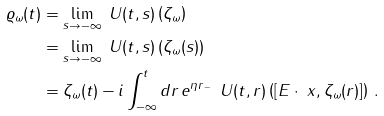Convert formula to latex. <formula><loc_0><loc_0><loc_500><loc_500>\varrho _ { \omega } ( t ) & = \lim _ { s \to - \infty } { \ U } ( t , s ) \left ( { \zeta } _ { \omega } \right ) \\ & = \lim _ { s \to - \infty } { \ U } ( t , s ) \left ( { \zeta } _ { \omega } ( s ) \right ) \\ & = { \zeta } _ { \omega } ( t ) - i \int _ { - \infty } ^ { t } d r \, e ^ { \eta r _ { \, - } } { \, \ U } ( t , r ) \left ( [ E \cdot \ x , { \zeta } _ { \omega } ( r ) ] \right ) \, .</formula> 